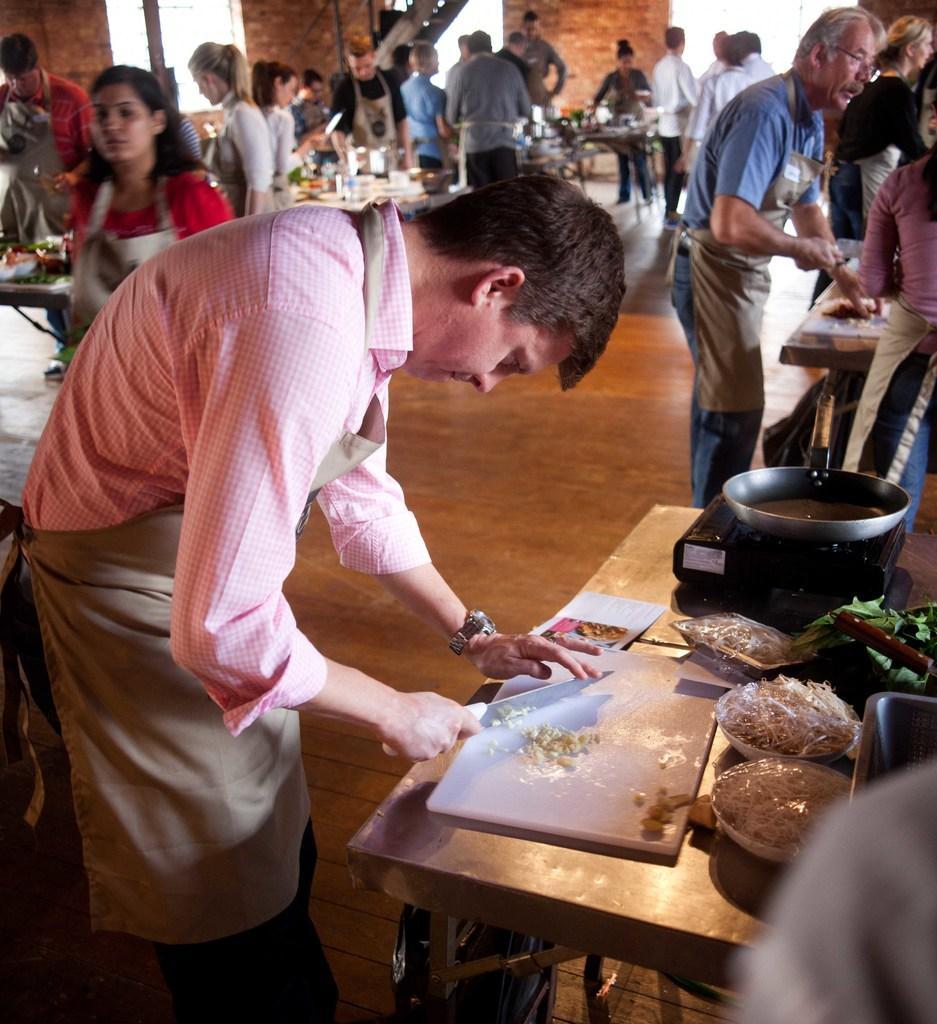How would you summarize this image in a sentence or two? In the image we can see there are many people standing, they are wearing clothes. There is a table, on the table there are food items, gas stove, pan, knife, this is wrist watch, stairs and other things. 